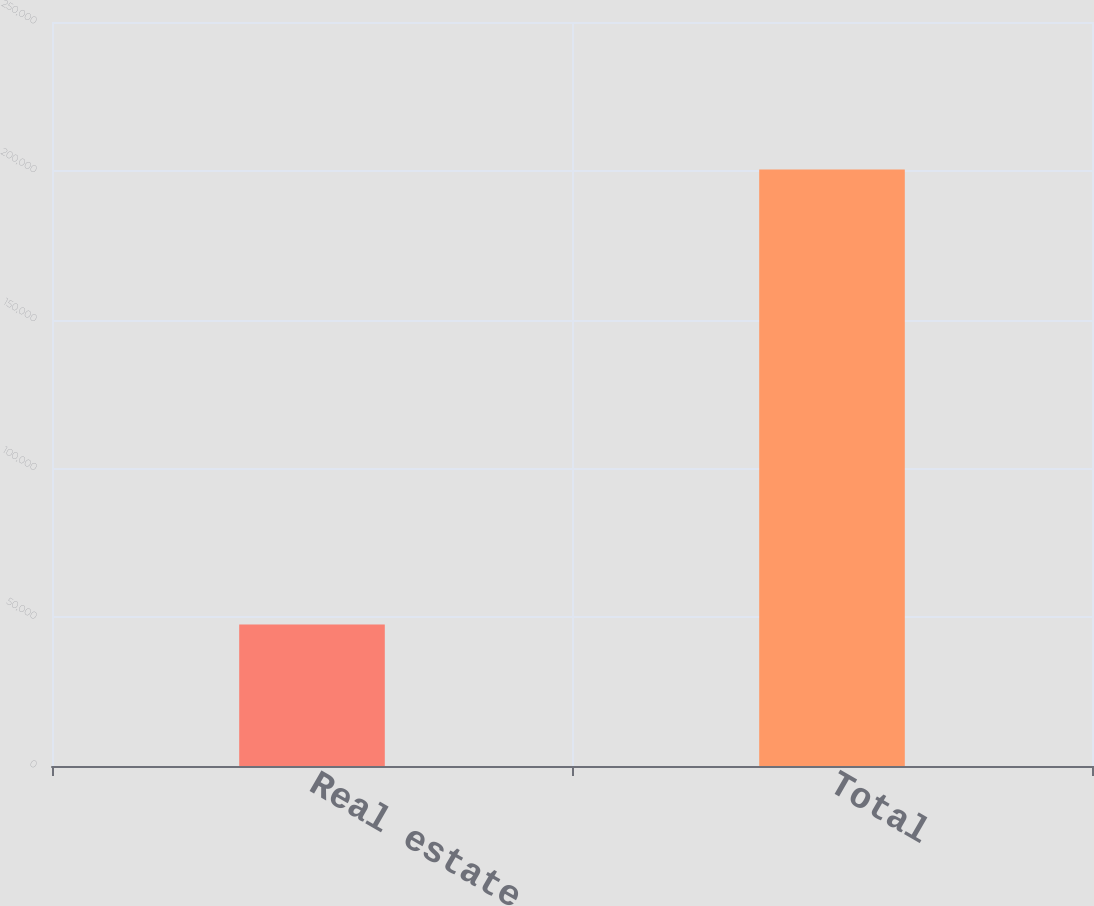<chart> <loc_0><loc_0><loc_500><loc_500><bar_chart><fcel>Real estate<fcel>Total<nl><fcel>47553<fcel>200402<nl></chart> 